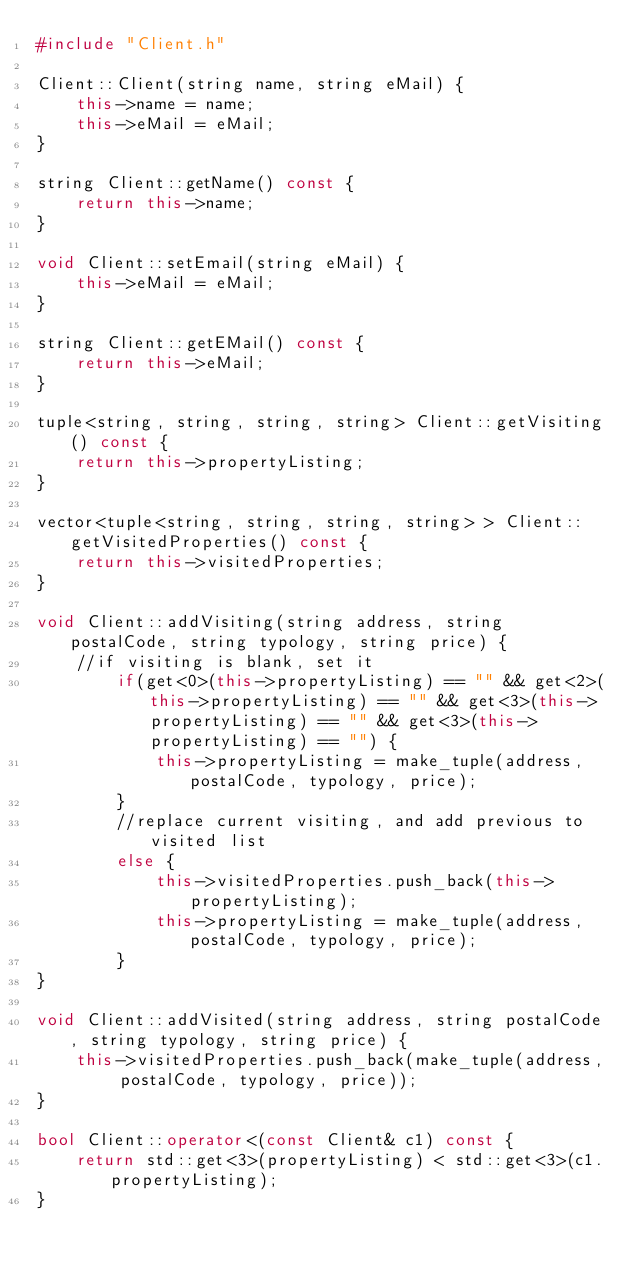<code> <loc_0><loc_0><loc_500><loc_500><_C++_>#include "Client.h"

Client::Client(string name, string eMail) {
	this->name = name;
	this->eMail = eMail;
}

string Client::getName() const {
	return this->name;
}

void Client::setEmail(string eMail) {
	this->eMail = eMail;
}

string Client::getEMail() const {
	return this->eMail;
}

tuple<string, string, string, string> Client::getVisiting() const {
	return this->propertyListing;
}

vector<tuple<string, string, string, string> > Client::getVisitedProperties() const {
	return this->visitedProperties;
}

void Client::addVisiting(string address, string postalCode, string typology, string price) {
	//if visiting is blank, set it
		if(get<0>(this->propertyListing) == "" && get<2>(this->propertyListing) == "" && get<3>(this->propertyListing) == "" && get<3>(this->propertyListing) == "") {
			this->propertyListing = make_tuple(address, postalCode, typology, price);
		}
		//replace current visiting, and add previous to visited list
		else {
			this->visitedProperties.push_back(this->propertyListing);
			this->propertyListing = make_tuple(address, postalCode, typology, price);
		}
}

void Client::addVisited(string address, string postalCode, string typology, string price) {
    this->visitedProperties.push_back(make_tuple(address, postalCode, typology, price));
}

bool Client::operator<(const Client& c1) const {
	return std::get<3>(propertyListing) < std::get<3>(c1.propertyListing);
}
</code> 